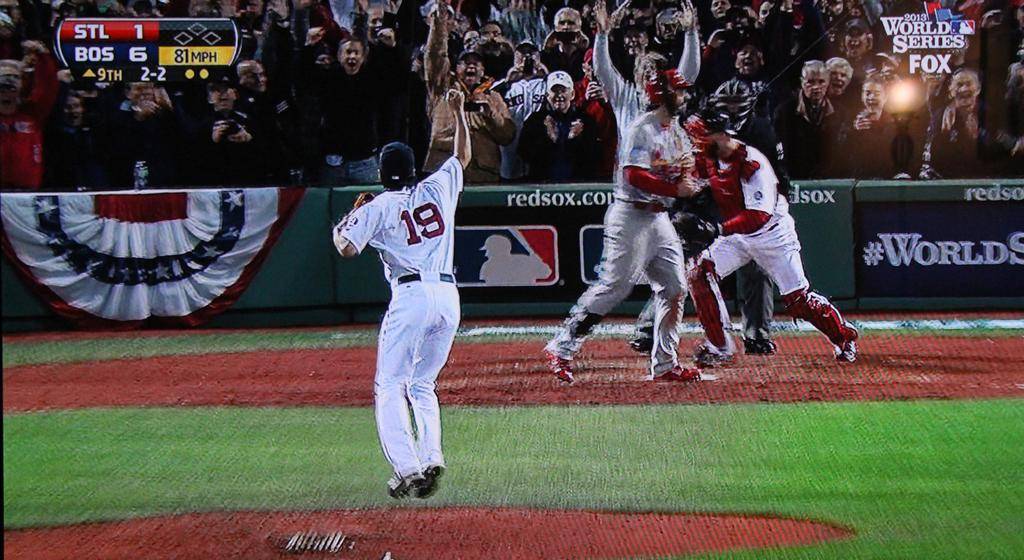<image>
Write a terse but informative summary of the picture. Baseball player w earing number 19 getting ready to cheer. 